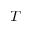<formula> <loc_0><loc_0><loc_500><loc_500>T</formula> 